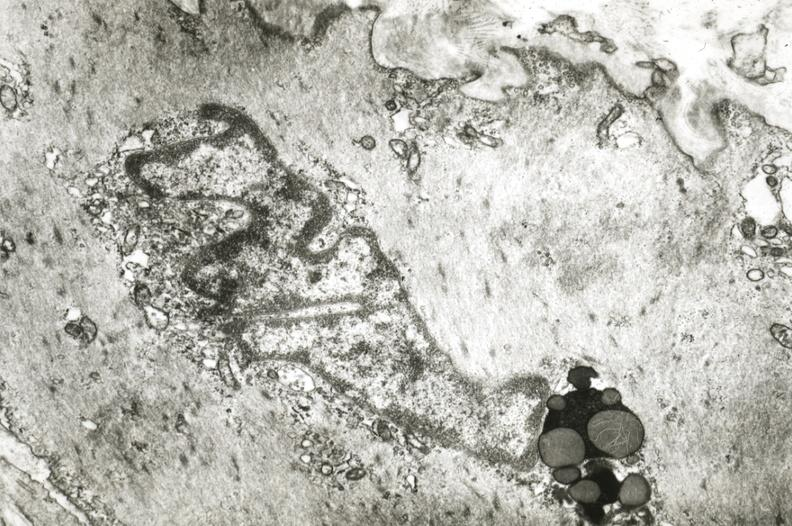what is present?
Answer the question using a single word or phrase. Cardiovascular 